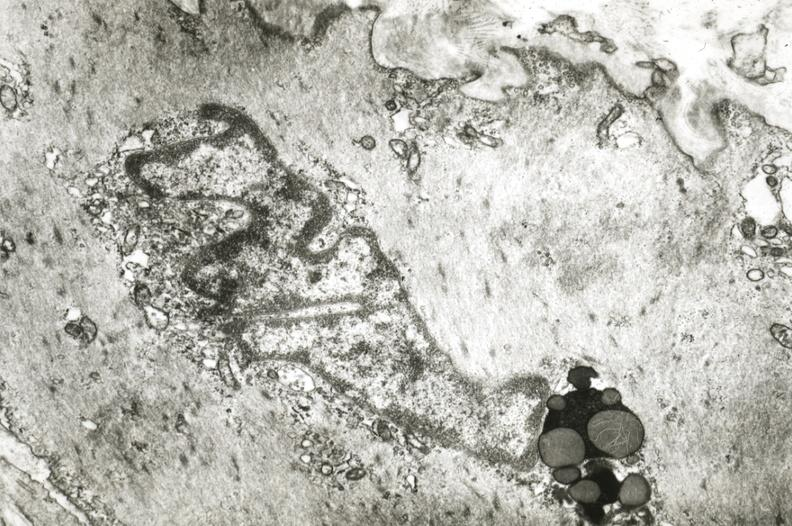what is present?
Answer the question using a single word or phrase. Cardiovascular 